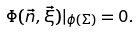<formula> <loc_0><loc_0><loc_500><loc_500>\Phi ( \vec { n } , \vec { \xi } ) | _ { \phi ( \Sigma ) } = 0 .</formula> 